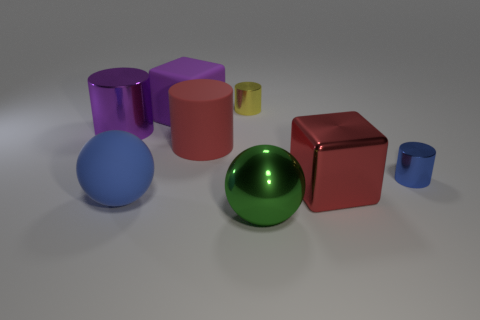Add 2 large purple cylinders. How many objects exist? 10 Subtract all spheres. How many objects are left? 6 Subtract all big cylinders. Subtract all tiny yellow metal objects. How many objects are left? 5 Add 3 large red shiny blocks. How many large red shiny blocks are left? 4 Add 6 yellow objects. How many yellow objects exist? 7 Subtract 0 yellow blocks. How many objects are left? 8 